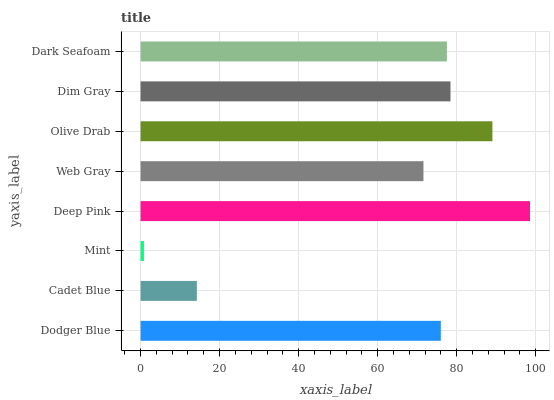Is Mint the minimum?
Answer yes or no. Yes. Is Deep Pink the maximum?
Answer yes or no. Yes. Is Cadet Blue the minimum?
Answer yes or no. No. Is Cadet Blue the maximum?
Answer yes or no. No. Is Dodger Blue greater than Cadet Blue?
Answer yes or no. Yes. Is Cadet Blue less than Dodger Blue?
Answer yes or no. Yes. Is Cadet Blue greater than Dodger Blue?
Answer yes or no. No. Is Dodger Blue less than Cadet Blue?
Answer yes or no. No. Is Dark Seafoam the high median?
Answer yes or no. Yes. Is Dodger Blue the low median?
Answer yes or no. Yes. Is Olive Drab the high median?
Answer yes or no. No. Is Mint the low median?
Answer yes or no. No. 